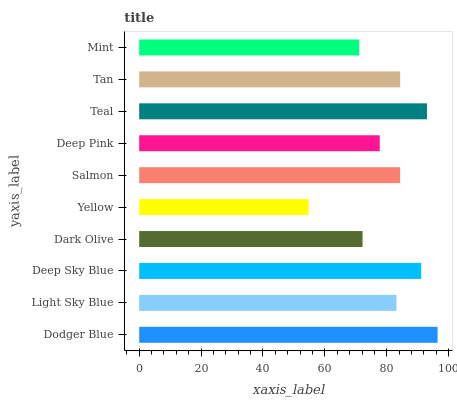Is Yellow the minimum?
Answer yes or no. Yes. Is Dodger Blue the maximum?
Answer yes or no. Yes. Is Light Sky Blue the minimum?
Answer yes or no. No. Is Light Sky Blue the maximum?
Answer yes or no. No. Is Dodger Blue greater than Light Sky Blue?
Answer yes or no. Yes. Is Light Sky Blue less than Dodger Blue?
Answer yes or no. Yes. Is Light Sky Blue greater than Dodger Blue?
Answer yes or no. No. Is Dodger Blue less than Light Sky Blue?
Answer yes or no. No. Is Salmon the high median?
Answer yes or no. Yes. Is Light Sky Blue the low median?
Answer yes or no. Yes. Is Light Sky Blue the high median?
Answer yes or no. No. Is Deep Pink the low median?
Answer yes or no. No. 